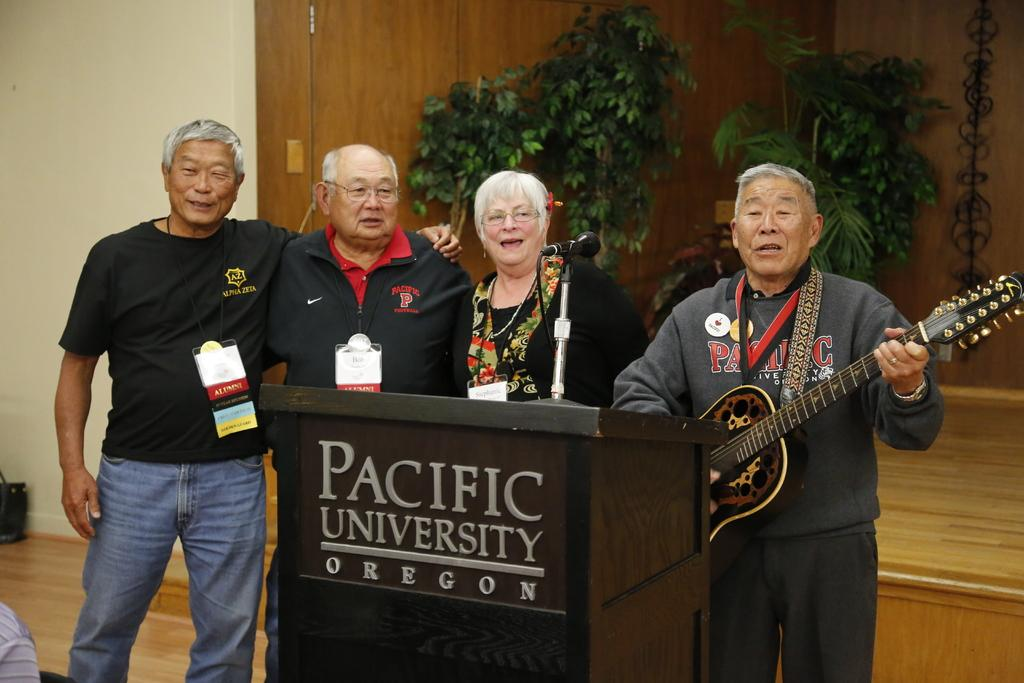How many people are in the image? There are four people in the image. What are the people doing in the image? The people are standing together and singing. What can be seen in the background of the image? There are plants visible in the background of the image. What type of book is the governor reading in the image? There is no governor or book present in the image. Are the people in the image sisters? The provided facts do not mention any familial relationships between the people in the image. 